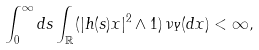<formula> <loc_0><loc_0><loc_500><loc_500>\int _ { 0 } ^ { \infty } d s \int _ { \mathbb { R } } ( | h ( s ) x | ^ { 2 } \wedge 1 ) \, \nu _ { Y } ( d x ) < \infty ,</formula> 